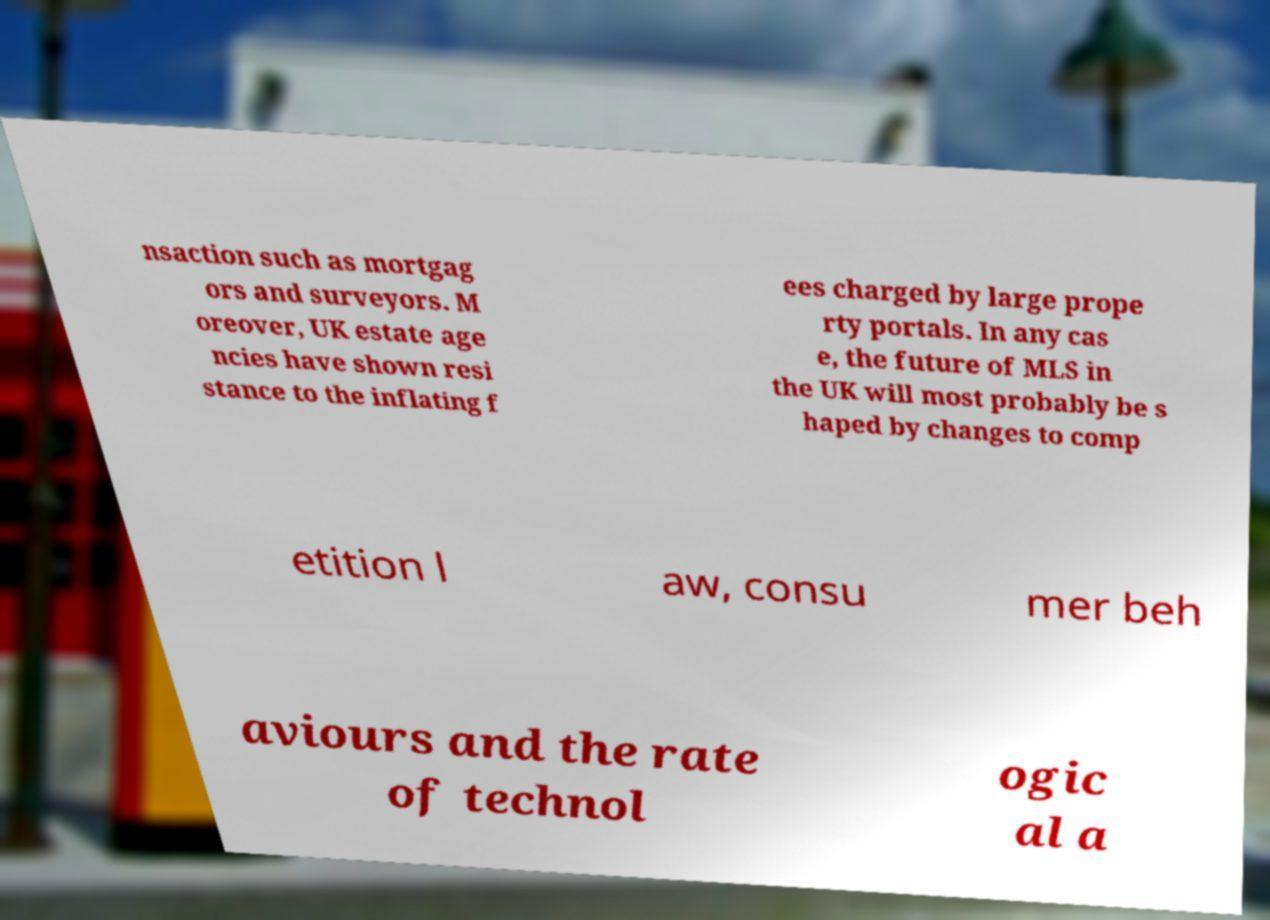For documentation purposes, I need the text within this image transcribed. Could you provide that? nsaction such as mortgag ors and surveyors. M oreover, UK estate age ncies have shown resi stance to the inflating f ees charged by large prope rty portals. In any cas e, the future of MLS in the UK will most probably be s haped by changes to comp etition l aw, consu mer beh aviours and the rate of technol ogic al a 